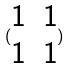<formula> <loc_0><loc_0><loc_500><loc_500>( \begin{matrix} 1 & 1 \\ 1 & 1 \end{matrix} )</formula> 